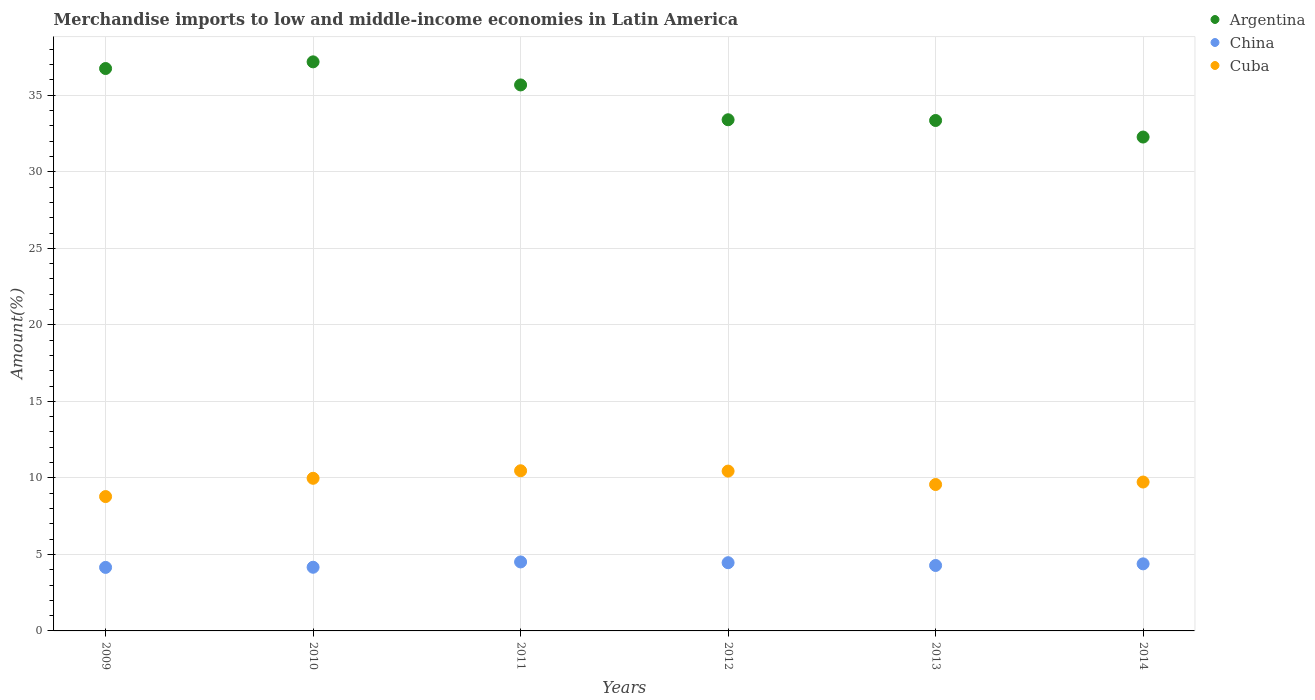How many different coloured dotlines are there?
Offer a terse response. 3. Is the number of dotlines equal to the number of legend labels?
Your answer should be very brief. Yes. What is the percentage of amount earned from merchandise imports in Argentina in 2009?
Your answer should be very brief. 36.75. Across all years, what is the maximum percentage of amount earned from merchandise imports in Cuba?
Keep it short and to the point. 10.47. Across all years, what is the minimum percentage of amount earned from merchandise imports in Argentina?
Provide a succinct answer. 32.27. What is the total percentage of amount earned from merchandise imports in Cuba in the graph?
Your answer should be very brief. 58.96. What is the difference between the percentage of amount earned from merchandise imports in Cuba in 2012 and that in 2014?
Your answer should be compact. 0.71. What is the difference between the percentage of amount earned from merchandise imports in China in 2014 and the percentage of amount earned from merchandise imports in Cuba in 2009?
Ensure brevity in your answer.  -4.4. What is the average percentage of amount earned from merchandise imports in Cuba per year?
Your answer should be compact. 9.83. In the year 2013, what is the difference between the percentage of amount earned from merchandise imports in China and percentage of amount earned from merchandise imports in Cuba?
Your answer should be compact. -5.29. In how many years, is the percentage of amount earned from merchandise imports in China greater than 7 %?
Your response must be concise. 0. What is the ratio of the percentage of amount earned from merchandise imports in Argentina in 2011 to that in 2012?
Ensure brevity in your answer.  1.07. Is the difference between the percentage of amount earned from merchandise imports in China in 2009 and 2011 greater than the difference between the percentage of amount earned from merchandise imports in Cuba in 2009 and 2011?
Provide a succinct answer. Yes. What is the difference between the highest and the second highest percentage of amount earned from merchandise imports in China?
Provide a short and direct response. 0.05. What is the difference between the highest and the lowest percentage of amount earned from merchandise imports in Cuba?
Your response must be concise. 1.69. In how many years, is the percentage of amount earned from merchandise imports in China greater than the average percentage of amount earned from merchandise imports in China taken over all years?
Provide a succinct answer. 3. Is it the case that in every year, the sum of the percentage of amount earned from merchandise imports in Cuba and percentage of amount earned from merchandise imports in China  is greater than the percentage of amount earned from merchandise imports in Argentina?
Make the answer very short. No. Does the percentage of amount earned from merchandise imports in Argentina monotonically increase over the years?
Give a very brief answer. No. Is the percentage of amount earned from merchandise imports in Cuba strictly less than the percentage of amount earned from merchandise imports in China over the years?
Offer a very short reply. No. How many dotlines are there?
Give a very brief answer. 3. How many years are there in the graph?
Your answer should be very brief. 6. What is the difference between two consecutive major ticks on the Y-axis?
Your response must be concise. 5. Does the graph contain grids?
Your response must be concise. Yes. Where does the legend appear in the graph?
Ensure brevity in your answer.  Top right. What is the title of the graph?
Your answer should be very brief. Merchandise imports to low and middle-income economies in Latin America. What is the label or title of the Y-axis?
Make the answer very short. Amount(%). What is the Amount(%) in Argentina in 2009?
Make the answer very short. 36.75. What is the Amount(%) in China in 2009?
Provide a succinct answer. 4.15. What is the Amount(%) in Cuba in 2009?
Your answer should be compact. 8.78. What is the Amount(%) in Argentina in 2010?
Ensure brevity in your answer.  37.18. What is the Amount(%) of China in 2010?
Offer a terse response. 4.16. What is the Amount(%) of Cuba in 2010?
Provide a succinct answer. 9.97. What is the Amount(%) in Argentina in 2011?
Provide a succinct answer. 35.68. What is the Amount(%) in China in 2011?
Provide a succinct answer. 4.51. What is the Amount(%) in Cuba in 2011?
Provide a succinct answer. 10.47. What is the Amount(%) in Argentina in 2012?
Give a very brief answer. 33.4. What is the Amount(%) of China in 2012?
Keep it short and to the point. 4.46. What is the Amount(%) of Cuba in 2012?
Keep it short and to the point. 10.44. What is the Amount(%) of Argentina in 2013?
Keep it short and to the point. 33.35. What is the Amount(%) in China in 2013?
Provide a succinct answer. 4.28. What is the Amount(%) in Cuba in 2013?
Offer a very short reply. 9.57. What is the Amount(%) of Argentina in 2014?
Make the answer very short. 32.27. What is the Amount(%) in China in 2014?
Provide a short and direct response. 4.38. What is the Amount(%) in Cuba in 2014?
Your response must be concise. 9.73. Across all years, what is the maximum Amount(%) in Argentina?
Offer a very short reply. 37.18. Across all years, what is the maximum Amount(%) in China?
Provide a short and direct response. 4.51. Across all years, what is the maximum Amount(%) in Cuba?
Offer a terse response. 10.47. Across all years, what is the minimum Amount(%) of Argentina?
Ensure brevity in your answer.  32.27. Across all years, what is the minimum Amount(%) of China?
Ensure brevity in your answer.  4.15. Across all years, what is the minimum Amount(%) of Cuba?
Your response must be concise. 8.78. What is the total Amount(%) in Argentina in the graph?
Your response must be concise. 208.63. What is the total Amount(%) of China in the graph?
Provide a short and direct response. 25.93. What is the total Amount(%) in Cuba in the graph?
Keep it short and to the point. 58.96. What is the difference between the Amount(%) of Argentina in 2009 and that in 2010?
Your answer should be very brief. -0.44. What is the difference between the Amount(%) of China in 2009 and that in 2010?
Offer a very short reply. -0.01. What is the difference between the Amount(%) of Cuba in 2009 and that in 2010?
Provide a succinct answer. -1.19. What is the difference between the Amount(%) of Argentina in 2009 and that in 2011?
Offer a terse response. 1.07. What is the difference between the Amount(%) in China in 2009 and that in 2011?
Ensure brevity in your answer.  -0.36. What is the difference between the Amount(%) in Cuba in 2009 and that in 2011?
Provide a succinct answer. -1.69. What is the difference between the Amount(%) of Argentina in 2009 and that in 2012?
Your answer should be very brief. 3.35. What is the difference between the Amount(%) in China in 2009 and that in 2012?
Your answer should be compact. -0.31. What is the difference between the Amount(%) of Cuba in 2009 and that in 2012?
Provide a short and direct response. -1.66. What is the difference between the Amount(%) of Argentina in 2009 and that in 2013?
Your response must be concise. 3.4. What is the difference between the Amount(%) in China in 2009 and that in 2013?
Provide a short and direct response. -0.12. What is the difference between the Amount(%) of Cuba in 2009 and that in 2013?
Ensure brevity in your answer.  -0.79. What is the difference between the Amount(%) in Argentina in 2009 and that in 2014?
Your answer should be very brief. 4.48. What is the difference between the Amount(%) of China in 2009 and that in 2014?
Your response must be concise. -0.23. What is the difference between the Amount(%) of Cuba in 2009 and that in 2014?
Ensure brevity in your answer.  -0.95. What is the difference between the Amount(%) in Argentina in 2010 and that in 2011?
Offer a terse response. 1.51. What is the difference between the Amount(%) of China in 2010 and that in 2011?
Offer a very short reply. -0.35. What is the difference between the Amount(%) of Cuba in 2010 and that in 2011?
Ensure brevity in your answer.  -0.49. What is the difference between the Amount(%) of Argentina in 2010 and that in 2012?
Offer a very short reply. 3.78. What is the difference between the Amount(%) of China in 2010 and that in 2012?
Offer a very short reply. -0.3. What is the difference between the Amount(%) in Cuba in 2010 and that in 2012?
Keep it short and to the point. -0.47. What is the difference between the Amount(%) of Argentina in 2010 and that in 2013?
Your answer should be very brief. 3.83. What is the difference between the Amount(%) in China in 2010 and that in 2013?
Your answer should be very brief. -0.12. What is the difference between the Amount(%) in Cuba in 2010 and that in 2013?
Offer a very short reply. 0.41. What is the difference between the Amount(%) in Argentina in 2010 and that in 2014?
Provide a succinct answer. 4.91. What is the difference between the Amount(%) of China in 2010 and that in 2014?
Offer a terse response. -0.22. What is the difference between the Amount(%) of Cuba in 2010 and that in 2014?
Offer a very short reply. 0.24. What is the difference between the Amount(%) in Argentina in 2011 and that in 2012?
Offer a terse response. 2.28. What is the difference between the Amount(%) of China in 2011 and that in 2012?
Provide a succinct answer. 0.05. What is the difference between the Amount(%) in Cuba in 2011 and that in 2012?
Provide a short and direct response. 0.02. What is the difference between the Amount(%) of Argentina in 2011 and that in 2013?
Provide a short and direct response. 2.32. What is the difference between the Amount(%) of China in 2011 and that in 2013?
Offer a terse response. 0.23. What is the difference between the Amount(%) of Cuba in 2011 and that in 2013?
Provide a succinct answer. 0.9. What is the difference between the Amount(%) of Argentina in 2011 and that in 2014?
Offer a very short reply. 3.41. What is the difference between the Amount(%) in China in 2011 and that in 2014?
Give a very brief answer. 0.12. What is the difference between the Amount(%) of Cuba in 2011 and that in 2014?
Make the answer very short. 0.74. What is the difference between the Amount(%) of Argentina in 2012 and that in 2013?
Your answer should be very brief. 0.05. What is the difference between the Amount(%) in China in 2012 and that in 2013?
Your answer should be very brief. 0.18. What is the difference between the Amount(%) of Cuba in 2012 and that in 2013?
Provide a succinct answer. 0.88. What is the difference between the Amount(%) of Argentina in 2012 and that in 2014?
Give a very brief answer. 1.13. What is the difference between the Amount(%) of China in 2012 and that in 2014?
Provide a succinct answer. 0.08. What is the difference between the Amount(%) of Cuba in 2012 and that in 2014?
Offer a terse response. 0.71. What is the difference between the Amount(%) of Argentina in 2013 and that in 2014?
Provide a short and direct response. 1.08. What is the difference between the Amount(%) of China in 2013 and that in 2014?
Give a very brief answer. -0.11. What is the difference between the Amount(%) in Cuba in 2013 and that in 2014?
Offer a terse response. -0.16. What is the difference between the Amount(%) of Argentina in 2009 and the Amount(%) of China in 2010?
Your answer should be compact. 32.59. What is the difference between the Amount(%) of Argentina in 2009 and the Amount(%) of Cuba in 2010?
Give a very brief answer. 26.77. What is the difference between the Amount(%) of China in 2009 and the Amount(%) of Cuba in 2010?
Give a very brief answer. -5.82. What is the difference between the Amount(%) of Argentina in 2009 and the Amount(%) of China in 2011?
Provide a succinct answer. 32.24. What is the difference between the Amount(%) in Argentina in 2009 and the Amount(%) in Cuba in 2011?
Keep it short and to the point. 26.28. What is the difference between the Amount(%) in China in 2009 and the Amount(%) in Cuba in 2011?
Give a very brief answer. -6.31. What is the difference between the Amount(%) in Argentina in 2009 and the Amount(%) in China in 2012?
Offer a very short reply. 32.29. What is the difference between the Amount(%) in Argentina in 2009 and the Amount(%) in Cuba in 2012?
Make the answer very short. 26.31. What is the difference between the Amount(%) in China in 2009 and the Amount(%) in Cuba in 2012?
Your answer should be compact. -6.29. What is the difference between the Amount(%) in Argentina in 2009 and the Amount(%) in China in 2013?
Offer a very short reply. 32.47. What is the difference between the Amount(%) in Argentina in 2009 and the Amount(%) in Cuba in 2013?
Make the answer very short. 27.18. What is the difference between the Amount(%) in China in 2009 and the Amount(%) in Cuba in 2013?
Your answer should be compact. -5.42. What is the difference between the Amount(%) of Argentina in 2009 and the Amount(%) of China in 2014?
Your response must be concise. 32.37. What is the difference between the Amount(%) in Argentina in 2009 and the Amount(%) in Cuba in 2014?
Give a very brief answer. 27.02. What is the difference between the Amount(%) of China in 2009 and the Amount(%) of Cuba in 2014?
Offer a very short reply. -5.58. What is the difference between the Amount(%) in Argentina in 2010 and the Amount(%) in China in 2011?
Offer a terse response. 32.68. What is the difference between the Amount(%) of Argentina in 2010 and the Amount(%) of Cuba in 2011?
Your answer should be compact. 26.72. What is the difference between the Amount(%) of China in 2010 and the Amount(%) of Cuba in 2011?
Offer a terse response. -6.31. What is the difference between the Amount(%) of Argentina in 2010 and the Amount(%) of China in 2012?
Ensure brevity in your answer.  32.73. What is the difference between the Amount(%) of Argentina in 2010 and the Amount(%) of Cuba in 2012?
Your answer should be compact. 26.74. What is the difference between the Amount(%) of China in 2010 and the Amount(%) of Cuba in 2012?
Your response must be concise. -6.28. What is the difference between the Amount(%) of Argentina in 2010 and the Amount(%) of China in 2013?
Provide a succinct answer. 32.91. What is the difference between the Amount(%) of Argentina in 2010 and the Amount(%) of Cuba in 2013?
Your answer should be compact. 27.62. What is the difference between the Amount(%) of China in 2010 and the Amount(%) of Cuba in 2013?
Your answer should be compact. -5.41. What is the difference between the Amount(%) of Argentina in 2010 and the Amount(%) of China in 2014?
Provide a succinct answer. 32.8. What is the difference between the Amount(%) of Argentina in 2010 and the Amount(%) of Cuba in 2014?
Provide a succinct answer. 27.46. What is the difference between the Amount(%) of China in 2010 and the Amount(%) of Cuba in 2014?
Your response must be concise. -5.57. What is the difference between the Amount(%) of Argentina in 2011 and the Amount(%) of China in 2012?
Your answer should be compact. 31.22. What is the difference between the Amount(%) of Argentina in 2011 and the Amount(%) of Cuba in 2012?
Provide a succinct answer. 25.23. What is the difference between the Amount(%) in China in 2011 and the Amount(%) in Cuba in 2012?
Provide a succinct answer. -5.94. What is the difference between the Amount(%) of Argentina in 2011 and the Amount(%) of China in 2013?
Make the answer very short. 31.4. What is the difference between the Amount(%) of Argentina in 2011 and the Amount(%) of Cuba in 2013?
Ensure brevity in your answer.  26.11. What is the difference between the Amount(%) in China in 2011 and the Amount(%) in Cuba in 2013?
Your response must be concise. -5.06. What is the difference between the Amount(%) in Argentina in 2011 and the Amount(%) in China in 2014?
Your response must be concise. 31.29. What is the difference between the Amount(%) of Argentina in 2011 and the Amount(%) of Cuba in 2014?
Your response must be concise. 25.95. What is the difference between the Amount(%) in China in 2011 and the Amount(%) in Cuba in 2014?
Ensure brevity in your answer.  -5.22. What is the difference between the Amount(%) in Argentina in 2012 and the Amount(%) in China in 2013?
Offer a very short reply. 29.12. What is the difference between the Amount(%) of Argentina in 2012 and the Amount(%) of Cuba in 2013?
Offer a very short reply. 23.83. What is the difference between the Amount(%) of China in 2012 and the Amount(%) of Cuba in 2013?
Ensure brevity in your answer.  -5.11. What is the difference between the Amount(%) in Argentina in 2012 and the Amount(%) in China in 2014?
Make the answer very short. 29.02. What is the difference between the Amount(%) in Argentina in 2012 and the Amount(%) in Cuba in 2014?
Give a very brief answer. 23.67. What is the difference between the Amount(%) in China in 2012 and the Amount(%) in Cuba in 2014?
Your response must be concise. -5.27. What is the difference between the Amount(%) in Argentina in 2013 and the Amount(%) in China in 2014?
Your answer should be very brief. 28.97. What is the difference between the Amount(%) in Argentina in 2013 and the Amount(%) in Cuba in 2014?
Your answer should be very brief. 23.62. What is the difference between the Amount(%) of China in 2013 and the Amount(%) of Cuba in 2014?
Your answer should be compact. -5.45. What is the average Amount(%) of Argentina per year?
Offer a very short reply. 34.77. What is the average Amount(%) of China per year?
Give a very brief answer. 4.32. What is the average Amount(%) of Cuba per year?
Keep it short and to the point. 9.83. In the year 2009, what is the difference between the Amount(%) in Argentina and Amount(%) in China?
Make the answer very short. 32.6. In the year 2009, what is the difference between the Amount(%) of Argentina and Amount(%) of Cuba?
Your response must be concise. 27.97. In the year 2009, what is the difference between the Amount(%) in China and Amount(%) in Cuba?
Your answer should be very brief. -4.63. In the year 2010, what is the difference between the Amount(%) in Argentina and Amount(%) in China?
Your response must be concise. 33.02. In the year 2010, what is the difference between the Amount(%) of Argentina and Amount(%) of Cuba?
Make the answer very short. 27.21. In the year 2010, what is the difference between the Amount(%) of China and Amount(%) of Cuba?
Your answer should be very brief. -5.81. In the year 2011, what is the difference between the Amount(%) in Argentina and Amount(%) in China?
Your answer should be very brief. 31.17. In the year 2011, what is the difference between the Amount(%) of Argentina and Amount(%) of Cuba?
Keep it short and to the point. 25.21. In the year 2011, what is the difference between the Amount(%) in China and Amount(%) in Cuba?
Provide a succinct answer. -5.96. In the year 2012, what is the difference between the Amount(%) of Argentina and Amount(%) of China?
Offer a very short reply. 28.94. In the year 2012, what is the difference between the Amount(%) in Argentina and Amount(%) in Cuba?
Keep it short and to the point. 22.96. In the year 2012, what is the difference between the Amount(%) in China and Amount(%) in Cuba?
Ensure brevity in your answer.  -5.99. In the year 2013, what is the difference between the Amount(%) of Argentina and Amount(%) of China?
Your answer should be very brief. 29.08. In the year 2013, what is the difference between the Amount(%) of Argentina and Amount(%) of Cuba?
Offer a terse response. 23.79. In the year 2013, what is the difference between the Amount(%) of China and Amount(%) of Cuba?
Provide a short and direct response. -5.29. In the year 2014, what is the difference between the Amount(%) of Argentina and Amount(%) of China?
Your answer should be very brief. 27.89. In the year 2014, what is the difference between the Amount(%) of Argentina and Amount(%) of Cuba?
Provide a succinct answer. 22.54. In the year 2014, what is the difference between the Amount(%) in China and Amount(%) in Cuba?
Provide a succinct answer. -5.35. What is the ratio of the Amount(%) of Argentina in 2009 to that in 2010?
Give a very brief answer. 0.99. What is the ratio of the Amount(%) of China in 2009 to that in 2010?
Ensure brevity in your answer.  1. What is the ratio of the Amount(%) of Cuba in 2009 to that in 2010?
Ensure brevity in your answer.  0.88. What is the ratio of the Amount(%) of Argentina in 2009 to that in 2011?
Offer a very short reply. 1.03. What is the ratio of the Amount(%) in China in 2009 to that in 2011?
Offer a very short reply. 0.92. What is the ratio of the Amount(%) of Cuba in 2009 to that in 2011?
Give a very brief answer. 0.84. What is the ratio of the Amount(%) of Argentina in 2009 to that in 2012?
Ensure brevity in your answer.  1.1. What is the ratio of the Amount(%) of China in 2009 to that in 2012?
Your answer should be compact. 0.93. What is the ratio of the Amount(%) in Cuba in 2009 to that in 2012?
Ensure brevity in your answer.  0.84. What is the ratio of the Amount(%) in Argentina in 2009 to that in 2013?
Your answer should be very brief. 1.1. What is the ratio of the Amount(%) of China in 2009 to that in 2013?
Ensure brevity in your answer.  0.97. What is the ratio of the Amount(%) in Cuba in 2009 to that in 2013?
Ensure brevity in your answer.  0.92. What is the ratio of the Amount(%) in Argentina in 2009 to that in 2014?
Ensure brevity in your answer.  1.14. What is the ratio of the Amount(%) of China in 2009 to that in 2014?
Keep it short and to the point. 0.95. What is the ratio of the Amount(%) in Cuba in 2009 to that in 2014?
Give a very brief answer. 0.9. What is the ratio of the Amount(%) in Argentina in 2010 to that in 2011?
Your answer should be compact. 1.04. What is the ratio of the Amount(%) in China in 2010 to that in 2011?
Keep it short and to the point. 0.92. What is the ratio of the Amount(%) in Cuba in 2010 to that in 2011?
Ensure brevity in your answer.  0.95. What is the ratio of the Amount(%) of Argentina in 2010 to that in 2012?
Offer a terse response. 1.11. What is the ratio of the Amount(%) in China in 2010 to that in 2012?
Make the answer very short. 0.93. What is the ratio of the Amount(%) in Cuba in 2010 to that in 2012?
Provide a short and direct response. 0.95. What is the ratio of the Amount(%) in Argentina in 2010 to that in 2013?
Give a very brief answer. 1.11. What is the ratio of the Amount(%) of China in 2010 to that in 2013?
Provide a short and direct response. 0.97. What is the ratio of the Amount(%) in Cuba in 2010 to that in 2013?
Your response must be concise. 1.04. What is the ratio of the Amount(%) of Argentina in 2010 to that in 2014?
Offer a terse response. 1.15. What is the ratio of the Amount(%) in China in 2010 to that in 2014?
Your response must be concise. 0.95. What is the ratio of the Amount(%) in Cuba in 2010 to that in 2014?
Your answer should be very brief. 1.03. What is the ratio of the Amount(%) in Argentina in 2011 to that in 2012?
Your answer should be very brief. 1.07. What is the ratio of the Amount(%) of China in 2011 to that in 2012?
Keep it short and to the point. 1.01. What is the ratio of the Amount(%) of Argentina in 2011 to that in 2013?
Make the answer very short. 1.07. What is the ratio of the Amount(%) in China in 2011 to that in 2013?
Offer a terse response. 1.05. What is the ratio of the Amount(%) of Cuba in 2011 to that in 2013?
Make the answer very short. 1.09. What is the ratio of the Amount(%) in Argentina in 2011 to that in 2014?
Give a very brief answer. 1.11. What is the ratio of the Amount(%) of China in 2011 to that in 2014?
Provide a succinct answer. 1.03. What is the ratio of the Amount(%) in Cuba in 2011 to that in 2014?
Your answer should be very brief. 1.08. What is the ratio of the Amount(%) in China in 2012 to that in 2013?
Give a very brief answer. 1.04. What is the ratio of the Amount(%) of Cuba in 2012 to that in 2013?
Ensure brevity in your answer.  1.09. What is the ratio of the Amount(%) in Argentina in 2012 to that in 2014?
Your answer should be very brief. 1.03. What is the ratio of the Amount(%) in China in 2012 to that in 2014?
Give a very brief answer. 1.02. What is the ratio of the Amount(%) of Cuba in 2012 to that in 2014?
Provide a short and direct response. 1.07. What is the ratio of the Amount(%) of Argentina in 2013 to that in 2014?
Your response must be concise. 1.03. What is the ratio of the Amount(%) of China in 2013 to that in 2014?
Offer a very short reply. 0.98. What is the ratio of the Amount(%) in Cuba in 2013 to that in 2014?
Offer a terse response. 0.98. What is the difference between the highest and the second highest Amount(%) of Argentina?
Your answer should be compact. 0.44. What is the difference between the highest and the second highest Amount(%) of China?
Provide a short and direct response. 0.05. What is the difference between the highest and the second highest Amount(%) of Cuba?
Your response must be concise. 0.02. What is the difference between the highest and the lowest Amount(%) in Argentina?
Your answer should be very brief. 4.91. What is the difference between the highest and the lowest Amount(%) of China?
Your response must be concise. 0.36. What is the difference between the highest and the lowest Amount(%) in Cuba?
Provide a short and direct response. 1.69. 